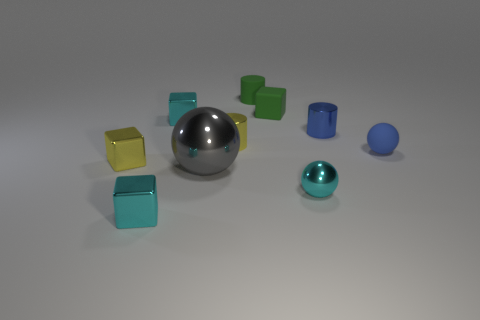How many cyan cubes must be subtracted to get 1 cyan cubes? 1 Subtract all rubber cubes. How many cubes are left? 3 Subtract all cyan spheres. How many spheres are left? 2 Subtract all balls. How many objects are left? 7 Subtract 3 balls. How many balls are left? 0 Subtract all tiny blue metal blocks. Subtract all matte cylinders. How many objects are left? 9 Add 1 blue rubber things. How many blue rubber things are left? 2 Add 2 large gray cylinders. How many large gray cylinders exist? 2 Subtract 0 red cylinders. How many objects are left? 10 Subtract all red cylinders. Subtract all green spheres. How many cylinders are left? 3 